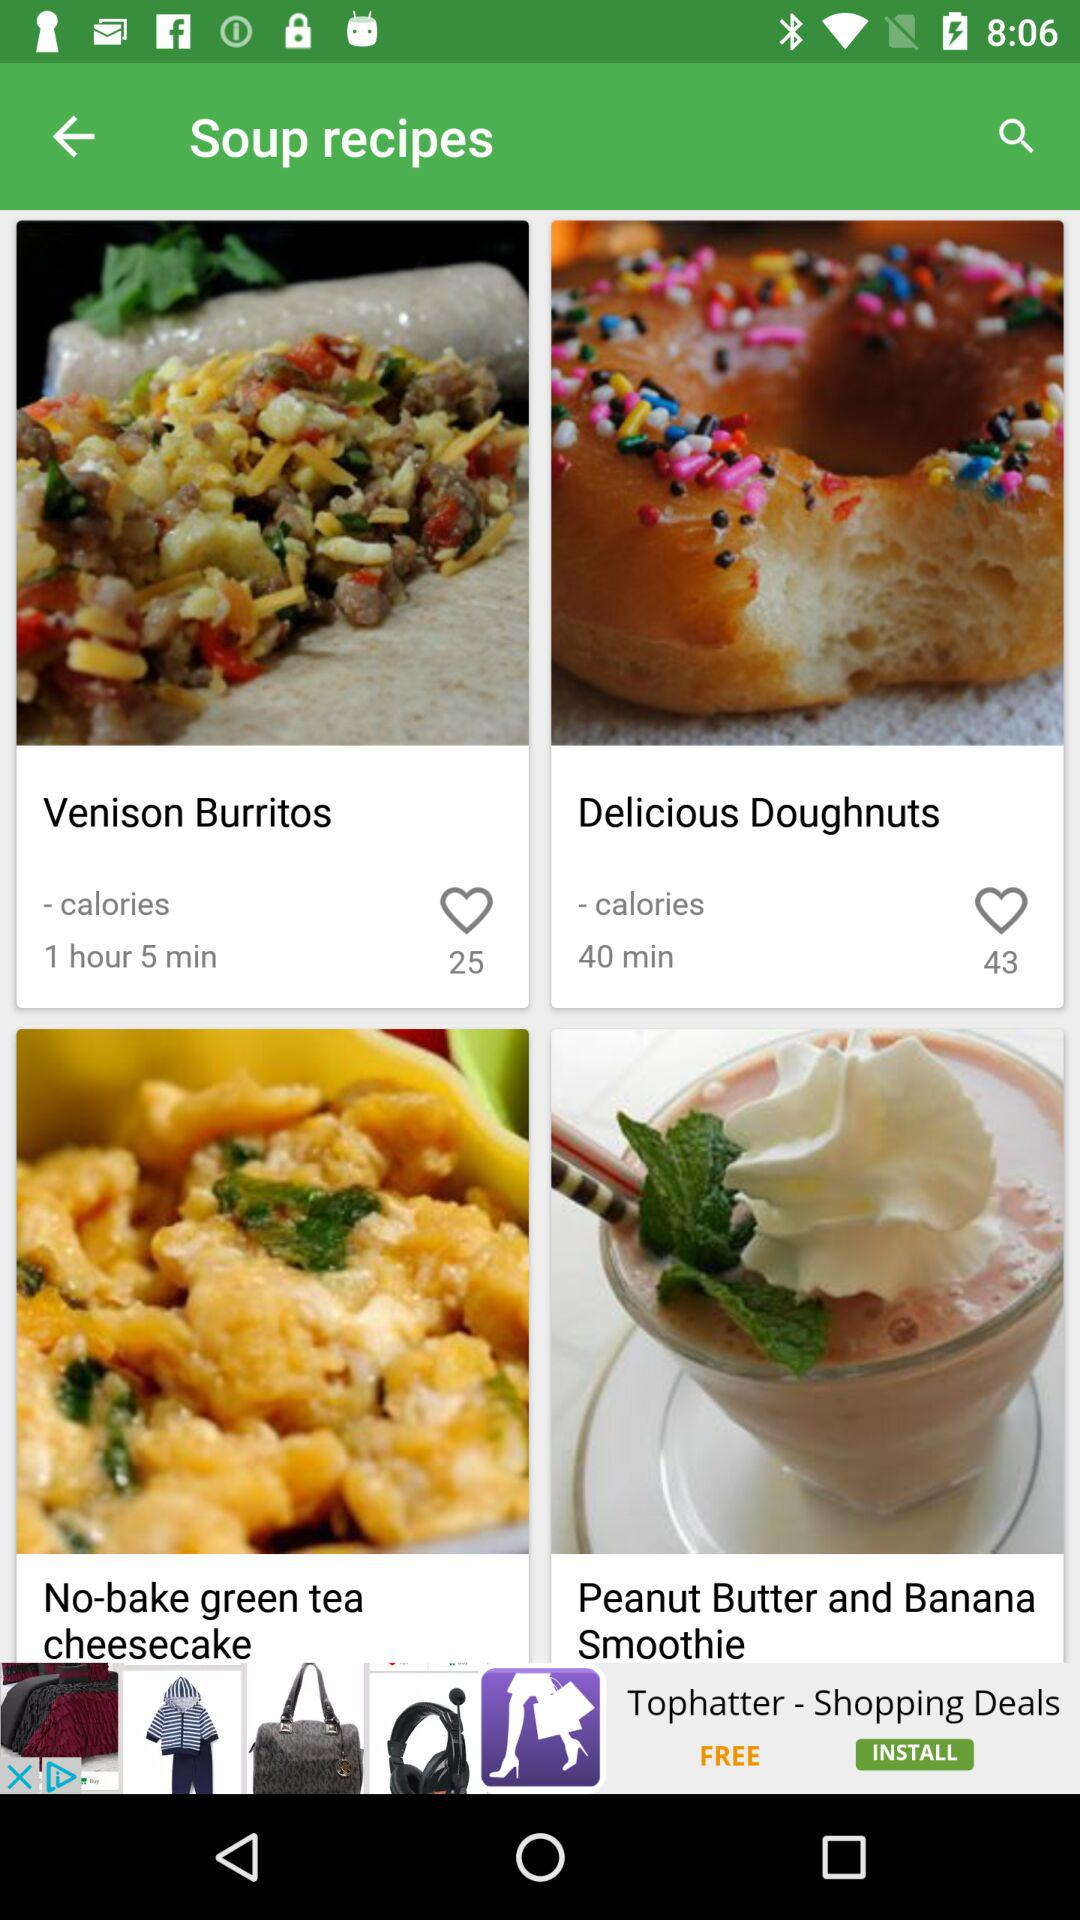How much time will it take to make the "Delicious Doughnuts"? It will take 40 minutes to make the "Delicious Doughnuts". 